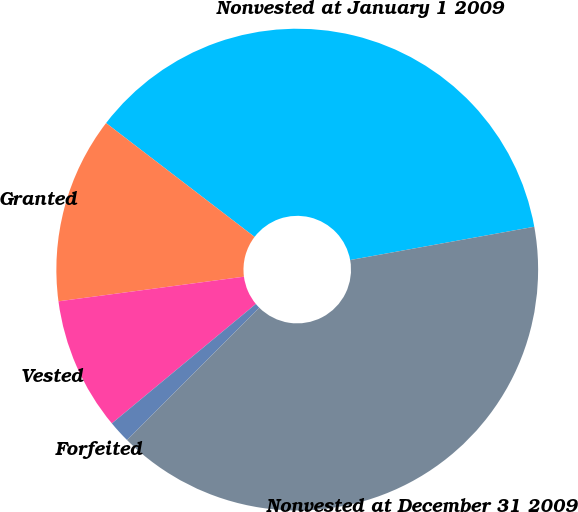<chart> <loc_0><loc_0><loc_500><loc_500><pie_chart><fcel>Nonvested at January 1 2009<fcel>Granted<fcel>Vested<fcel>Forfeited<fcel>Nonvested at December 31 2009<nl><fcel>36.74%<fcel>12.51%<fcel>8.92%<fcel>1.49%<fcel>40.33%<nl></chart> 